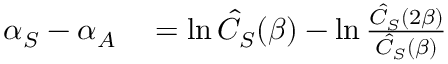<formula> <loc_0><loc_0><loc_500><loc_500>\begin{array} { r l } { \alpha _ { S } - \alpha _ { A } } & = \ln \hat { C } _ { S } ( \beta ) - \ln \frac { \hat { C } _ { S } ( 2 \beta ) } { \hat { C } _ { S } ( \beta ) } } \end{array}</formula> 